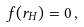Convert formula to latex. <formula><loc_0><loc_0><loc_500><loc_500>f ( r _ { H } ) = 0 \, ,</formula> 